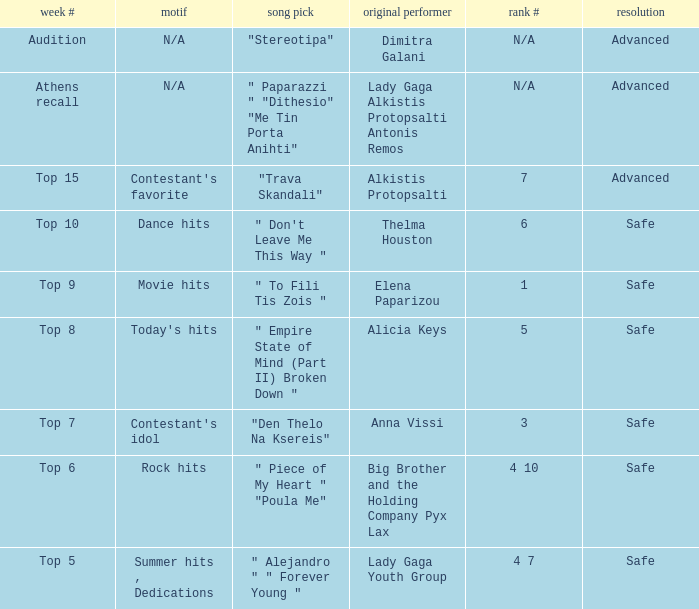Which song was chosen during the audition week? "Stereotipa". 